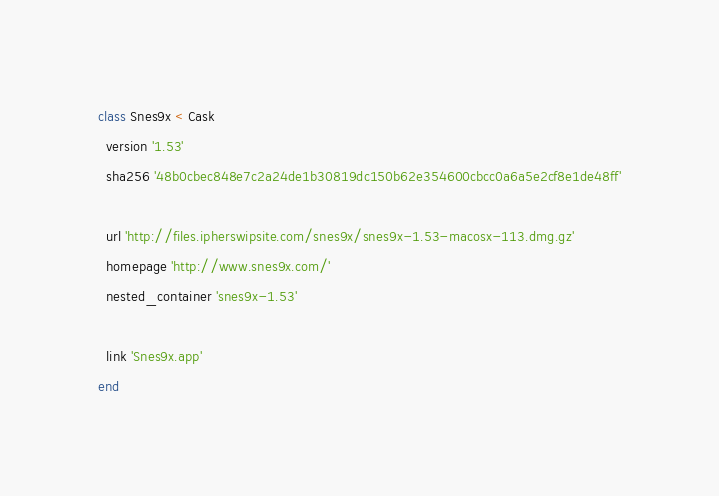Convert code to text. <code><loc_0><loc_0><loc_500><loc_500><_Ruby_>class Snes9x < Cask
  version '1.53'
  sha256 '48b0cbec848e7c2a24de1b30819dc150b62e354600cbcc0a6a5e2cf8e1de48ff'

  url 'http://files.ipherswipsite.com/snes9x/snes9x-1.53-macosx-113.dmg.gz'
  homepage 'http://www.snes9x.com/'
  nested_container 'snes9x-1.53'

  link 'Snes9x.app'
end
</code> 